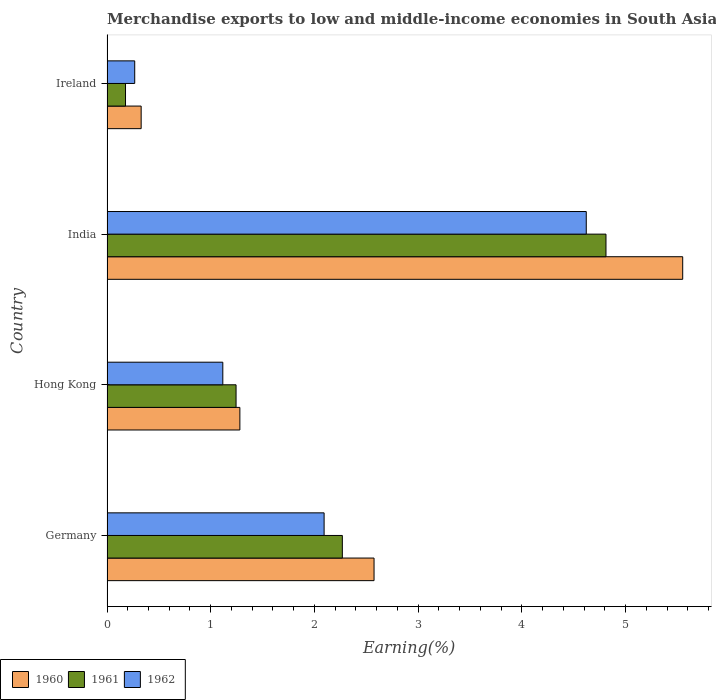How many different coloured bars are there?
Your answer should be compact. 3. Are the number of bars per tick equal to the number of legend labels?
Your answer should be compact. Yes. How many bars are there on the 4th tick from the bottom?
Keep it short and to the point. 3. What is the label of the 1st group of bars from the top?
Provide a short and direct response. Ireland. In how many cases, is the number of bars for a given country not equal to the number of legend labels?
Provide a succinct answer. 0. What is the percentage of amount earned from merchandise exports in 1960 in Germany?
Your answer should be very brief. 2.57. Across all countries, what is the maximum percentage of amount earned from merchandise exports in 1960?
Keep it short and to the point. 5.55. Across all countries, what is the minimum percentage of amount earned from merchandise exports in 1962?
Provide a short and direct response. 0.27. In which country was the percentage of amount earned from merchandise exports in 1960 maximum?
Your response must be concise. India. In which country was the percentage of amount earned from merchandise exports in 1960 minimum?
Provide a succinct answer. Ireland. What is the total percentage of amount earned from merchandise exports in 1961 in the graph?
Offer a very short reply. 8.5. What is the difference between the percentage of amount earned from merchandise exports in 1960 in Hong Kong and that in Ireland?
Offer a very short reply. 0.95. What is the difference between the percentage of amount earned from merchandise exports in 1961 in India and the percentage of amount earned from merchandise exports in 1960 in Ireland?
Your answer should be very brief. 4.48. What is the average percentage of amount earned from merchandise exports in 1961 per country?
Ensure brevity in your answer.  2.13. What is the difference between the percentage of amount earned from merchandise exports in 1961 and percentage of amount earned from merchandise exports in 1960 in Ireland?
Your answer should be very brief. -0.15. In how many countries, is the percentage of amount earned from merchandise exports in 1961 greater than 0.8 %?
Make the answer very short. 3. What is the ratio of the percentage of amount earned from merchandise exports in 1961 in India to that in Ireland?
Make the answer very short. 26.95. Is the percentage of amount earned from merchandise exports in 1961 in Germany less than that in Ireland?
Provide a succinct answer. No. What is the difference between the highest and the second highest percentage of amount earned from merchandise exports in 1962?
Ensure brevity in your answer.  2.53. What is the difference between the highest and the lowest percentage of amount earned from merchandise exports in 1962?
Your response must be concise. 4.35. In how many countries, is the percentage of amount earned from merchandise exports in 1960 greater than the average percentage of amount earned from merchandise exports in 1960 taken over all countries?
Offer a terse response. 2. Is the sum of the percentage of amount earned from merchandise exports in 1961 in Germany and Ireland greater than the maximum percentage of amount earned from merchandise exports in 1960 across all countries?
Provide a succinct answer. No. Is it the case that in every country, the sum of the percentage of amount earned from merchandise exports in 1961 and percentage of amount earned from merchandise exports in 1960 is greater than the percentage of amount earned from merchandise exports in 1962?
Keep it short and to the point. Yes. How many bars are there?
Your response must be concise. 12. Are all the bars in the graph horizontal?
Give a very brief answer. Yes. What is the difference between two consecutive major ticks on the X-axis?
Keep it short and to the point. 1. Are the values on the major ticks of X-axis written in scientific E-notation?
Give a very brief answer. No. Does the graph contain any zero values?
Make the answer very short. No. Where does the legend appear in the graph?
Your answer should be very brief. Bottom left. How many legend labels are there?
Give a very brief answer. 3. How are the legend labels stacked?
Your response must be concise. Horizontal. What is the title of the graph?
Provide a short and direct response. Merchandise exports to low and middle-income economies in South Asia. Does "2008" appear as one of the legend labels in the graph?
Offer a terse response. No. What is the label or title of the X-axis?
Your response must be concise. Earning(%). What is the label or title of the Y-axis?
Keep it short and to the point. Country. What is the Earning(%) in 1960 in Germany?
Keep it short and to the point. 2.57. What is the Earning(%) of 1961 in Germany?
Your response must be concise. 2.27. What is the Earning(%) in 1962 in Germany?
Ensure brevity in your answer.  2.09. What is the Earning(%) in 1960 in Hong Kong?
Offer a terse response. 1.28. What is the Earning(%) of 1961 in Hong Kong?
Your response must be concise. 1.24. What is the Earning(%) in 1962 in Hong Kong?
Give a very brief answer. 1.12. What is the Earning(%) in 1960 in India?
Ensure brevity in your answer.  5.55. What is the Earning(%) in 1961 in India?
Offer a terse response. 4.81. What is the Earning(%) of 1962 in India?
Offer a very short reply. 4.62. What is the Earning(%) of 1960 in Ireland?
Offer a very short reply. 0.33. What is the Earning(%) in 1961 in Ireland?
Keep it short and to the point. 0.18. What is the Earning(%) in 1962 in Ireland?
Your answer should be compact. 0.27. Across all countries, what is the maximum Earning(%) of 1960?
Your answer should be compact. 5.55. Across all countries, what is the maximum Earning(%) of 1961?
Your answer should be compact. 4.81. Across all countries, what is the maximum Earning(%) of 1962?
Ensure brevity in your answer.  4.62. Across all countries, what is the minimum Earning(%) of 1960?
Keep it short and to the point. 0.33. Across all countries, what is the minimum Earning(%) of 1961?
Provide a short and direct response. 0.18. Across all countries, what is the minimum Earning(%) of 1962?
Provide a short and direct response. 0.27. What is the total Earning(%) in 1960 in the graph?
Keep it short and to the point. 9.73. What is the total Earning(%) in 1961 in the graph?
Ensure brevity in your answer.  8.5. What is the total Earning(%) in 1962 in the graph?
Provide a short and direct response. 8.1. What is the difference between the Earning(%) of 1960 in Germany and that in Hong Kong?
Provide a short and direct response. 1.29. What is the difference between the Earning(%) of 1961 in Germany and that in Hong Kong?
Your answer should be compact. 1.02. What is the difference between the Earning(%) in 1962 in Germany and that in Hong Kong?
Ensure brevity in your answer.  0.98. What is the difference between the Earning(%) of 1960 in Germany and that in India?
Your answer should be compact. -2.98. What is the difference between the Earning(%) in 1961 in Germany and that in India?
Make the answer very short. -2.54. What is the difference between the Earning(%) of 1962 in Germany and that in India?
Your response must be concise. -2.53. What is the difference between the Earning(%) of 1960 in Germany and that in Ireland?
Ensure brevity in your answer.  2.25. What is the difference between the Earning(%) in 1961 in Germany and that in Ireland?
Offer a terse response. 2.09. What is the difference between the Earning(%) in 1962 in Germany and that in Ireland?
Provide a succinct answer. 1.83. What is the difference between the Earning(%) in 1960 in Hong Kong and that in India?
Your answer should be very brief. -4.27. What is the difference between the Earning(%) of 1961 in Hong Kong and that in India?
Offer a very short reply. -3.57. What is the difference between the Earning(%) in 1962 in Hong Kong and that in India?
Keep it short and to the point. -3.5. What is the difference between the Earning(%) of 1960 in Hong Kong and that in Ireland?
Offer a very short reply. 0.95. What is the difference between the Earning(%) of 1961 in Hong Kong and that in Ireland?
Your answer should be compact. 1.07. What is the difference between the Earning(%) in 1962 in Hong Kong and that in Ireland?
Your response must be concise. 0.85. What is the difference between the Earning(%) in 1960 in India and that in Ireland?
Provide a short and direct response. 5.22. What is the difference between the Earning(%) in 1961 in India and that in Ireland?
Make the answer very short. 4.63. What is the difference between the Earning(%) of 1962 in India and that in Ireland?
Give a very brief answer. 4.35. What is the difference between the Earning(%) in 1960 in Germany and the Earning(%) in 1961 in Hong Kong?
Keep it short and to the point. 1.33. What is the difference between the Earning(%) in 1960 in Germany and the Earning(%) in 1962 in Hong Kong?
Your response must be concise. 1.46. What is the difference between the Earning(%) of 1961 in Germany and the Earning(%) of 1962 in Hong Kong?
Give a very brief answer. 1.15. What is the difference between the Earning(%) of 1960 in Germany and the Earning(%) of 1961 in India?
Your answer should be very brief. -2.24. What is the difference between the Earning(%) in 1960 in Germany and the Earning(%) in 1962 in India?
Keep it short and to the point. -2.05. What is the difference between the Earning(%) of 1961 in Germany and the Earning(%) of 1962 in India?
Your answer should be compact. -2.35. What is the difference between the Earning(%) in 1960 in Germany and the Earning(%) in 1961 in Ireland?
Give a very brief answer. 2.4. What is the difference between the Earning(%) of 1960 in Germany and the Earning(%) of 1962 in Ireland?
Your answer should be very brief. 2.31. What is the difference between the Earning(%) of 1961 in Germany and the Earning(%) of 1962 in Ireland?
Keep it short and to the point. 2. What is the difference between the Earning(%) in 1960 in Hong Kong and the Earning(%) in 1961 in India?
Ensure brevity in your answer.  -3.53. What is the difference between the Earning(%) in 1960 in Hong Kong and the Earning(%) in 1962 in India?
Your answer should be compact. -3.34. What is the difference between the Earning(%) in 1961 in Hong Kong and the Earning(%) in 1962 in India?
Your answer should be very brief. -3.38. What is the difference between the Earning(%) of 1960 in Hong Kong and the Earning(%) of 1961 in Ireland?
Your answer should be compact. 1.1. What is the difference between the Earning(%) of 1960 in Hong Kong and the Earning(%) of 1962 in Ireland?
Offer a very short reply. 1.01. What is the difference between the Earning(%) of 1961 in Hong Kong and the Earning(%) of 1962 in Ireland?
Your response must be concise. 0.98. What is the difference between the Earning(%) of 1960 in India and the Earning(%) of 1961 in Ireland?
Provide a short and direct response. 5.37. What is the difference between the Earning(%) of 1960 in India and the Earning(%) of 1962 in Ireland?
Provide a succinct answer. 5.28. What is the difference between the Earning(%) of 1961 in India and the Earning(%) of 1962 in Ireland?
Offer a very short reply. 4.54. What is the average Earning(%) in 1960 per country?
Your answer should be compact. 2.43. What is the average Earning(%) of 1961 per country?
Make the answer very short. 2.13. What is the average Earning(%) of 1962 per country?
Keep it short and to the point. 2.02. What is the difference between the Earning(%) of 1960 and Earning(%) of 1961 in Germany?
Your answer should be very brief. 0.31. What is the difference between the Earning(%) of 1960 and Earning(%) of 1962 in Germany?
Your answer should be very brief. 0.48. What is the difference between the Earning(%) in 1961 and Earning(%) in 1962 in Germany?
Offer a very short reply. 0.18. What is the difference between the Earning(%) in 1960 and Earning(%) in 1961 in Hong Kong?
Keep it short and to the point. 0.04. What is the difference between the Earning(%) in 1960 and Earning(%) in 1962 in Hong Kong?
Your response must be concise. 0.16. What is the difference between the Earning(%) in 1961 and Earning(%) in 1962 in Hong Kong?
Offer a very short reply. 0.13. What is the difference between the Earning(%) in 1960 and Earning(%) in 1961 in India?
Your response must be concise. 0.74. What is the difference between the Earning(%) of 1960 and Earning(%) of 1962 in India?
Ensure brevity in your answer.  0.93. What is the difference between the Earning(%) of 1961 and Earning(%) of 1962 in India?
Give a very brief answer. 0.19. What is the difference between the Earning(%) in 1960 and Earning(%) in 1961 in Ireland?
Offer a very short reply. 0.15. What is the difference between the Earning(%) of 1960 and Earning(%) of 1962 in Ireland?
Give a very brief answer. 0.06. What is the difference between the Earning(%) in 1961 and Earning(%) in 1962 in Ireland?
Your answer should be very brief. -0.09. What is the ratio of the Earning(%) in 1960 in Germany to that in Hong Kong?
Your answer should be very brief. 2.01. What is the ratio of the Earning(%) in 1961 in Germany to that in Hong Kong?
Keep it short and to the point. 1.82. What is the ratio of the Earning(%) in 1962 in Germany to that in Hong Kong?
Keep it short and to the point. 1.87. What is the ratio of the Earning(%) in 1960 in Germany to that in India?
Offer a very short reply. 0.46. What is the ratio of the Earning(%) of 1961 in Germany to that in India?
Give a very brief answer. 0.47. What is the ratio of the Earning(%) of 1962 in Germany to that in India?
Your answer should be very brief. 0.45. What is the ratio of the Earning(%) of 1960 in Germany to that in Ireland?
Offer a very short reply. 7.82. What is the ratio of the Earning(%) of 1961 in Germany to that in Ireland?
Provide a short and direct response. 12.71. What is the ratio of the Earning(%) in 1962 in Germany to that in Ireland?
Your answer should be compact. 7.83. What is the ratio of the Earning(%) in 1960 in Hong Kong to that in India?
Your response must be concise. 0.23. What is the ratio of the Earning(%) in 1961 in Hong Kong to that in India?
Ensure brevity in your answer.  0.26. What is the ratio of the Earning(%) of 1962 in Hong Kong to that in India?
Give a very brief answer. 0.24. What is the ratio of the Earning(%) in 1960 in Hong Kong to that in Ireland?
Offer a very short reply. 3.89. What is the ratio of the Earning(%) of 1961 in Hong Kong to that in Ireland?
Your answer should be very brief. 6.97. What is the ratio of the Earning(%) in 1962 in Hong Kong to that in Ireland?
Your response must be concise. 4.18. What is the ratio of the Earning(%) in 1960 in India to that in Ireland?
Your answer should be very brief. 16.86. What is the ratio of the Earning(%) of 1961 in India to that in Ireland?
Provide a succinct answer. 26.95. What is the ratio of the Earning(%) in 1962 in India to that in Ireland?
Give a very brief answer. 17.29. What is the difference between the highest and the second highest Earning(%) of 1960?
Provide a succinct answer. 2.98. What is the difference between the highest and the second highest Earning(%) of 1961?
Your answer should be compact. 2.54. What is the difference between the highest and the second highest Earning(%) of 1962?
Your answer should be very brief. 2.53. What is the difference between the highest and the lowest Earning(%) in 1960?
Offer a terse response. 5.22. What is the difference between the highest and the lowest Earning(%) of 1961?
Your answer should be compact. 4.63. What is the difference between the highest and the lowest Earning(%) of 1962?
Your answer should be very brief. 4.35. 